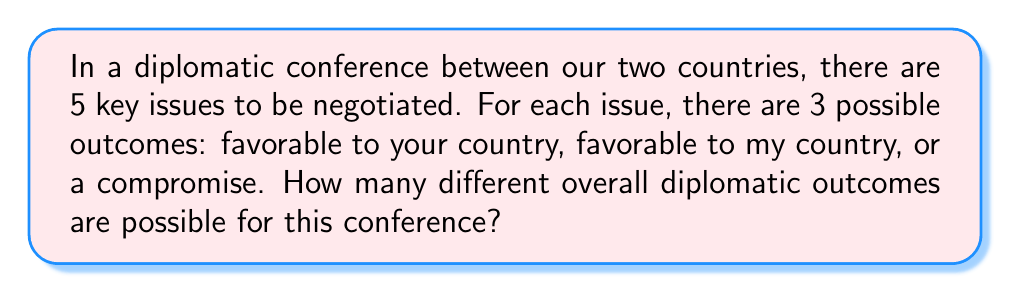Teach me how to tackle this problem. Let's approach this step-by-step using the multiplication principle of combinatorics:

1) For each issue, there are 3 possible outcomes:
   - Favorable to your country
   - Favorable to my country
   - Compromise

2) We have 5 independent issues to be negotiated.

3) For each issue, we make a choice from the 3 possible outcomes, and we do this 5 times (once for each issue).

4) The multiplication principle states that if we have a sequence of $n$ independent choices, where the $i$-th choice has $k_i$ options, then the total number of possible outcomes is the product of the number of options for each choice.

5) In this case, we have 5 choices (issues), and each choice has 3 options.

6) Therefore, the total number of possible diplomatic outcomes is:

   $$ 3 \times 3 \times 3 \times 3 \times 3 = 3^5 $$

7) Computing this:
   $$ 3^5 = 3 \times 3 \times 3 \times 3 \times 3 = 243 $$

Thus, there are 243 possible overall diplomatic outcomes for this conference.
Answer: $3^5 = 243$ 